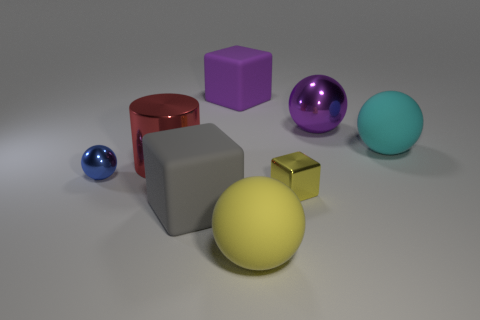What is the shape of the yellow thing that is the same material as the purple ball? cube 